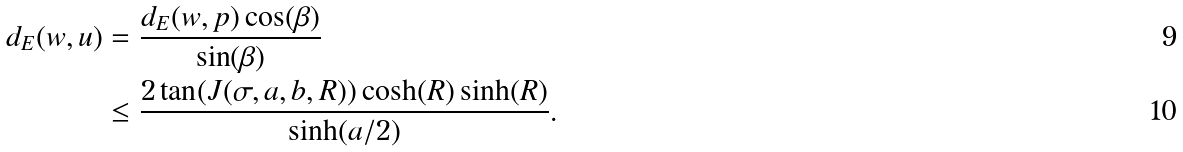Convert formula to latex. <formula><loc_0><loc_0><loc_500><loc_500>d _ { E } ( w , u ) & = \frac { d _ { E } ( w , p ) \cos ( \beta ) } { \sin ( \beta ) } \\ & \leq \frac { 2 \tan ( J ( \sigma , a , b , R ) ) \cosh ( R ) \sinh ( R ) } { \sinh ( a / 2 ) } .</formula> 